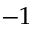<formula> <loc_0><loc_0><loc_500><loc_500>- 1</formula> 